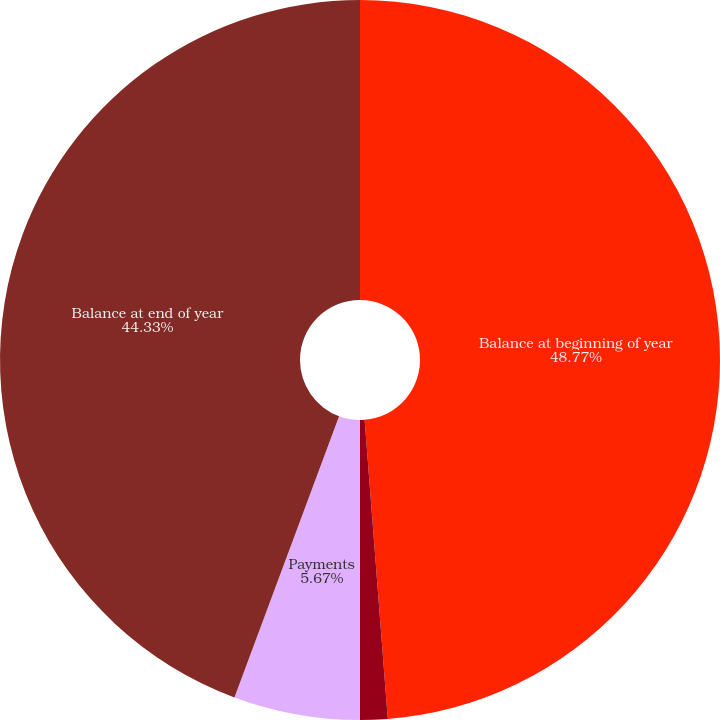Convert chart. <chart><loc_0><loc_0><loc_500><loc_500><pie_chart><fcel>Balance at beginning of year<fcel>Accretion<fcel>Payments<fcel>Balance at end of year<nl><fcel>48.77%<fcel>1.23%<fcel>5.67%<fcel>44.33%<nl></chart> 